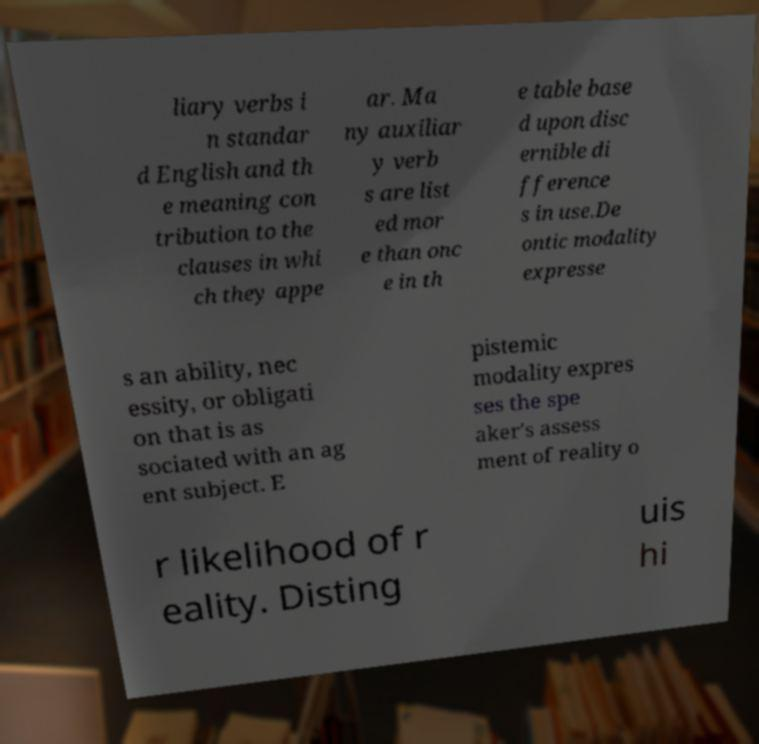Can you accurately transcribe the text from the provided image for me? liary verbs i n standar d English and th e meaning con tribution to the clauses in whi ch they appe ar. Ma ny auxiliar y verb s are list ed mor e than onc e in th e table base d upon disc ernible di fference s in use.De ontic modality expresse s an ability, nec essity, or obligati on that is as sociated with an ag ent subject. E pistemic modality expres ses the spe aker's assess ment of reality o r likelihood of r eality. Disting uis hi 